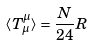Convert formula to latex. <formula><loc_0><loc_0><loc_500><loc_500>\langle T _ { \mu } ^ { \mu } \rangle = \frac { N } { 2 4 } R</formula> 